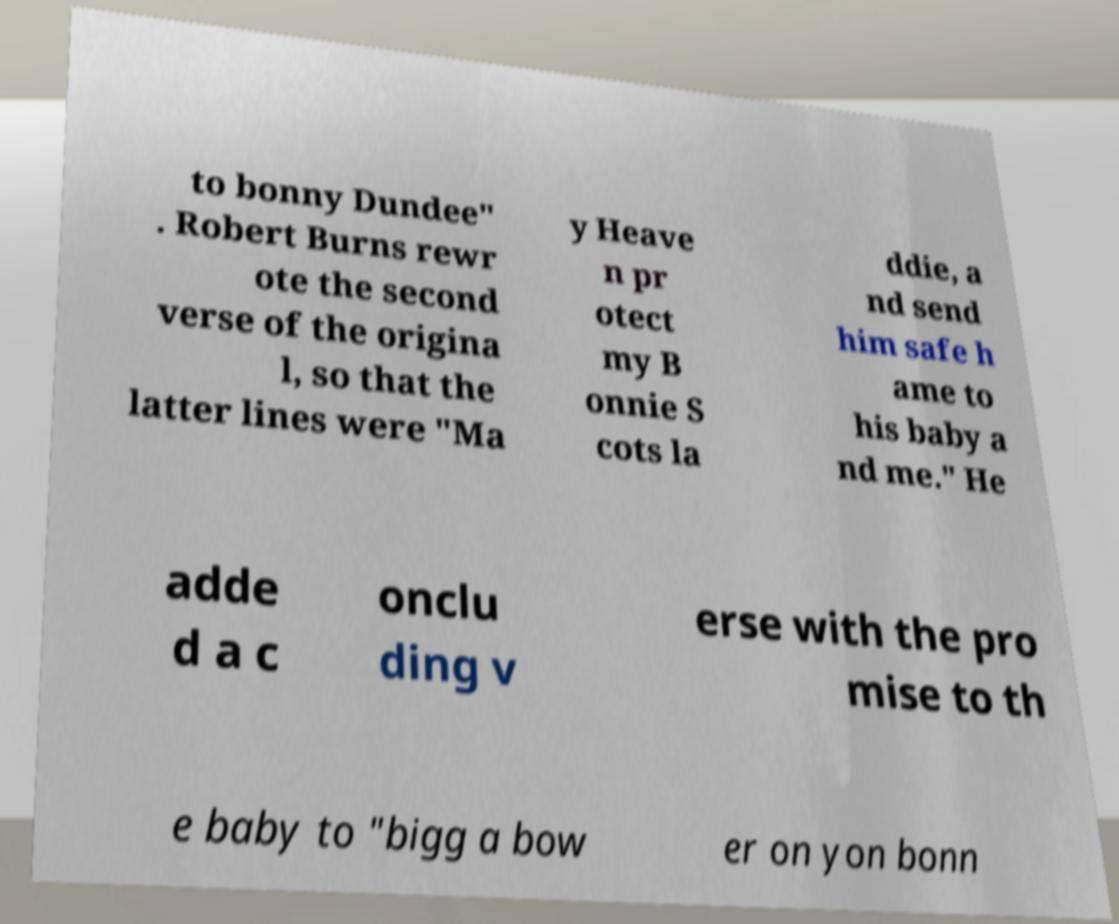Please read and relay the text visible in this image. What does it say? to bonny Dundee" . Robert Burns rewr ote the second verse of the origina l, so that the latter lines were "Ma y Heave n pr otect my B onnie S cots la ddie, a nd send him safe h ame to his baby a nd me." He adde d a c onclu ding v erse with the pro mise to th e baby to "bigg a bow er on yon bonn 